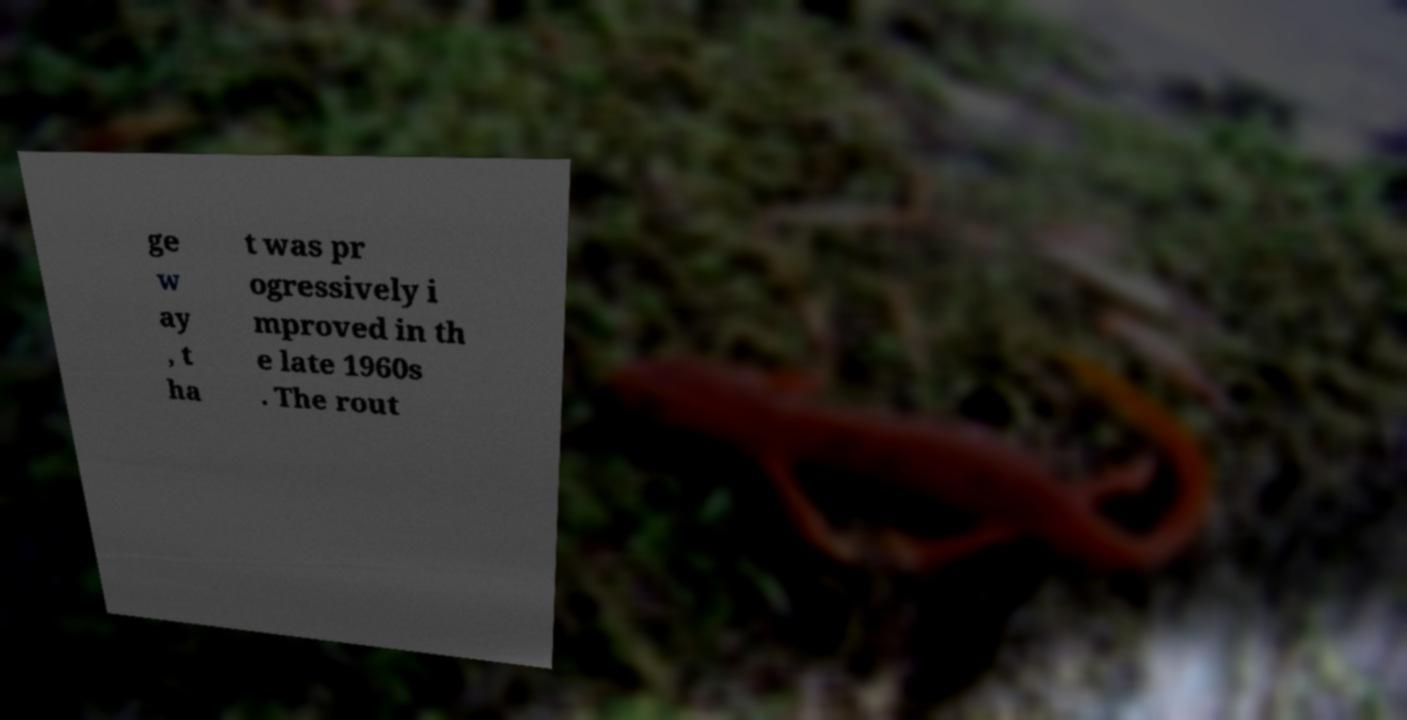Can you read and provide the text displayed in the image?This photo seems to have some interesting text. Can you extract and type it out for me? ge w ay , t ha t was pr ogressively i mproved in th e late 1960s . The rout 